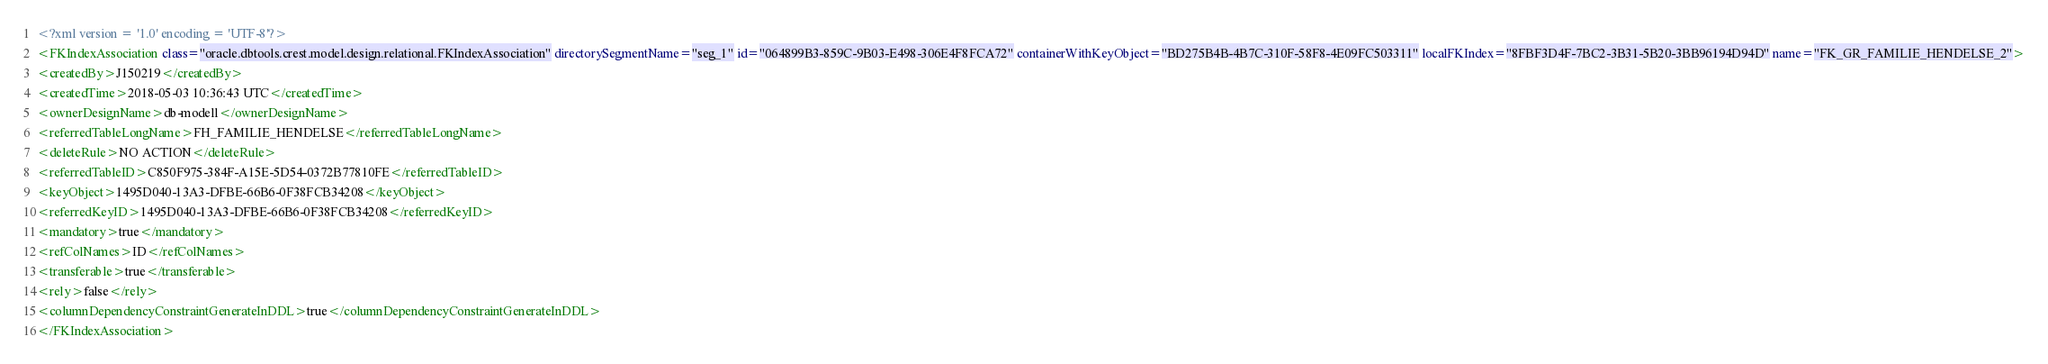Convert code to text. <code><loc_0><loc_0><loc_500><loc_500><_XML_><?xml version = '1.0' encoding = 'UTF-8'?>
<FKIndexAssociation class="oracle.dbtools.crest.model.design.relational.FKIndexAssociation" directorySegmentName="seg_1" id="064899B3-859C-9B03-E498-306E4F8FCA72" containerWithKeyObject="BD275B4B-4B7C-310F-58F8-4E09FC503311" localFKIndex="8FBF3D4F-7BC2-3B31-5B20-3BB96194D94D" name="FK_GR_FAMILIE_HENDELSE_2">
<createdBy>J150219</createdBy>
<createdTime>2018-05-03 10:36:43 UTC</createdTime>
<ownerDesignName>db-modell</ownerDesignName>
<referredTableLongName>FH_FAMILIE_HENDELSE</referredTableLongName>
<deleteRule>NO ACTION</deleteRule>
<referredTableID>C850F975-384F-A15E-5D54-0372B77810FE</referredTableID>
<keyObject>1495D040-13A3-DFBE-66B6-0F38FCB34208</keyObject>
<referredKeyID>1495D040-13A3-DFBE-66B6-0F38FCB34208</referredKeyID>
<mandatory>true</mandatory>
<refColNames>ID</refColNames>
<transferable>true</transferable>
<rely>false</rely>
<columnDependencyConstraintGenerateInDDL>true</columnDependencyConstraintGenerateInDDL>
</FKIndexAssociation></code> 